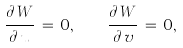Convert formula to latex. <formula><loc_0><loc_0><loc_500><loc_500>\frac { \partial \, W } { \partial \, u } \, = \, 0 , \quad \frac { \partial \, W } { \partial \, v } \, = \, 0 ,</formula> 